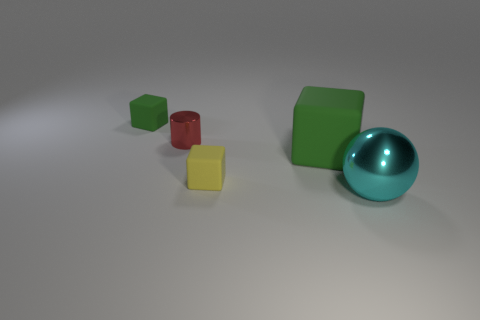Subtract all green cubes. How many were subtracted if there are1green cubes left? 1 Add 1 tiny green rubber things. How many objects exist? 6 Subtract all cubes. How many objects are left? 2 Add 4 green matte things. How many green matte things are left? 6 Add 2 big cyan spheres. How many big cyan spheres exist? 3 Subtract 0 yellow cylinders. How many objects are left? 5 Subtract all tiny things. Subtract all small brown shiny things. How many objects are left? 2 